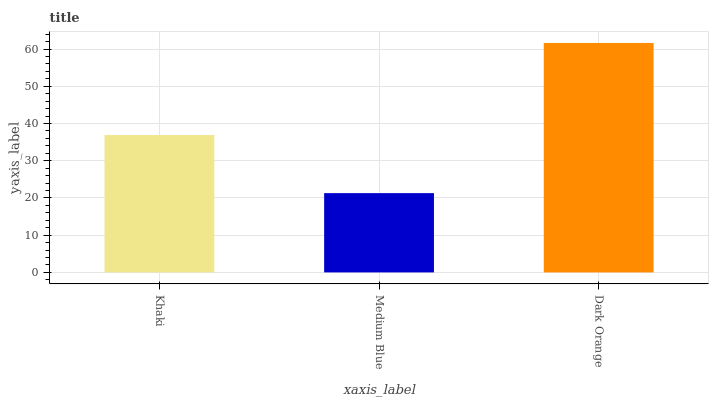Is Medium Blue the minimum?
Answer yes or no. Yes. Is Dark Orange the maximum?
Answer yes or no. Yes. Is Dark Orange the minimum?
Answer yes or no. No. Is Medium Blue the maximum?
Answer yes or no. No. Is Dark Orange greater than Medium Blue?
Answer yes or no. Yes. Is Medium Blue less than Dark Orange?
Answer yes or no. Yes. Is Medium Blue greater than Dark Orange?
Answer yes or no. No. Is Dark Orange less than Medium Blue?
Answer yes or no. No. Is Khaki the high median?
Answer yes or no. Yes. Is Khaki the low median?
Answer yes or no. Yes. Is Dark Orange the high median?
Answer yes or no. No. Is Dark Orange the low median?
Answer yes or no. No. 